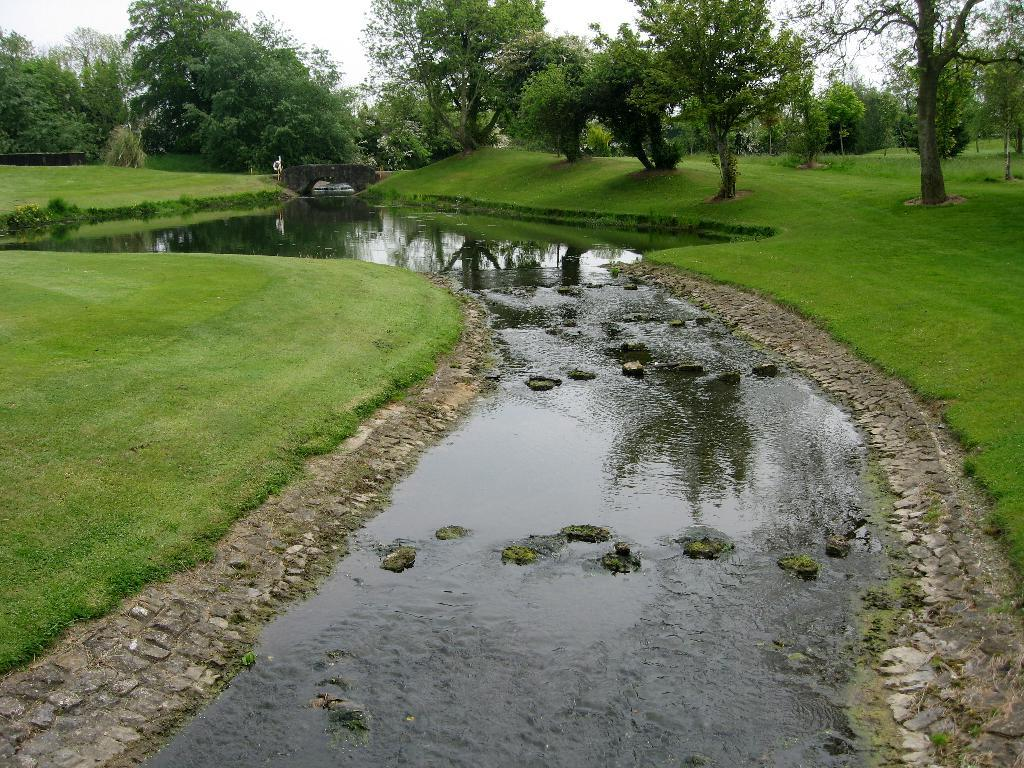What type of vegetation is present on both sides of the image? There is grass on both the left and right sides of the image. What is located in the middle of the image? There is water in the middle of the image. What can be seen in the background of the image? There are trees visible in the background of the image. Can you tell me how many pickles are floating in the water in the image? There are no pickles present in the image; it features grass, water, and trees. What type of bridge is visible in the image? There is no bridge present in the image. 